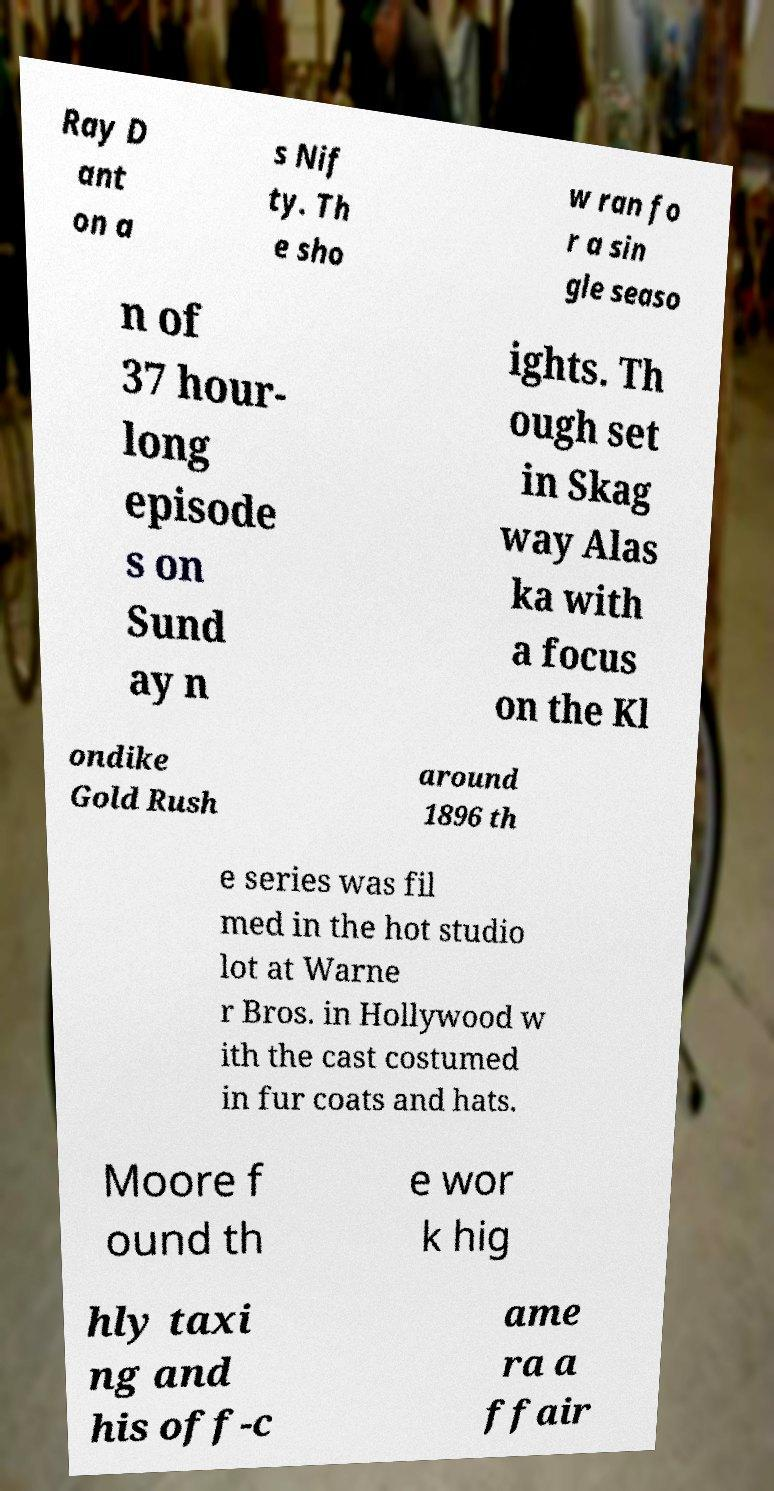Could you assist in decoding the text presented in this image and type it out clearly? Ray D ant on a s Nif ty. Th e sho w ran fo r a sin gle seaso n of 37 hour- long episode s on Sund ay n ights. Th ough set in Skag way Alas ka with a focus on the Kl ondike Gold Rush around 1896 th e series was fil med in the hot studio lot at Warne r Bros. in Hollywood w ith the cast costumed in fur coats and hats. Moore f ound th e wor k hig hly taxi ng and his off-c ame ra a ffair 